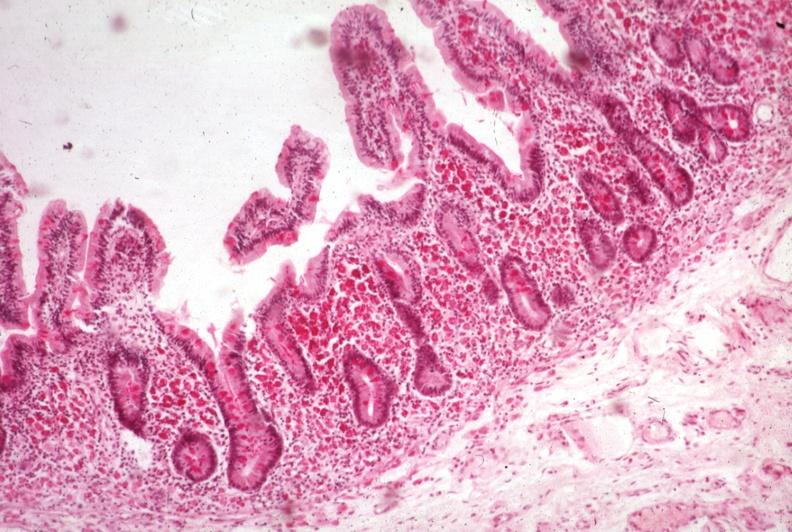s gastrointestinal present?
Answer the question using a single word or phrase. Yes 